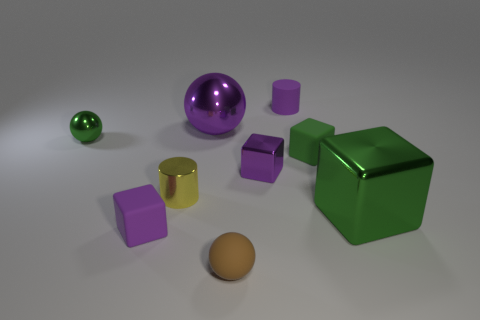Subtract all cubes. How many objects are left? 5 Subtract 0 blue cubes. How many objects are left? 9 Subtract all big green matte cylinders. Subtract all tiny brown rubber things. How many objects are left? 8 Add 9 small metal cylinders. How many small metal cylinders are left? 10 Add 7 tiny red matte blocks. How many tiny red matte blocks exist? 7 